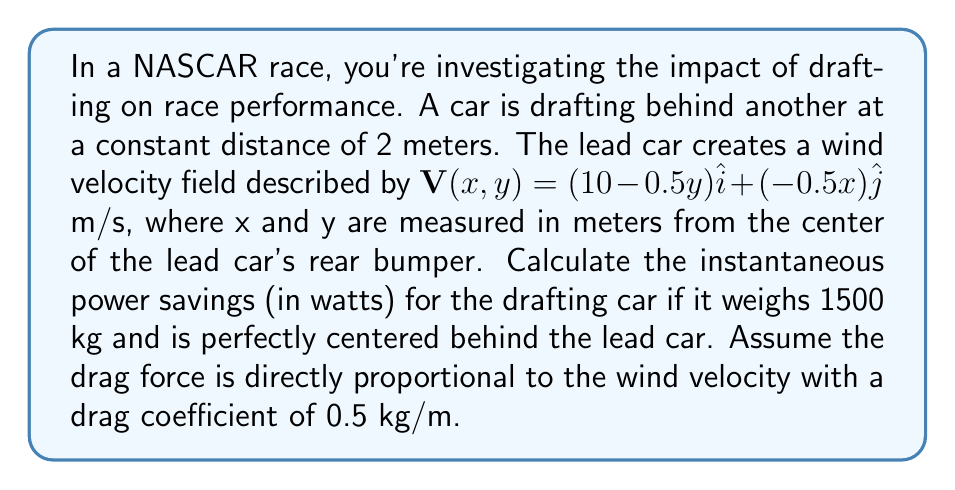Could you help me with this problem? To solve this problem, we'll follow these steps:

1) First, we need to find the wind velocity at the position of the drafting car. The car is 2 meters directly behind the lead car, so its position is (0, -2) in our coordinate system.

2) Plug this position into the vector field equation:
   $\mathbf{V}(0,-2) = (10-0.5(-2))\hat{i} + (-0.5(0))\hat{j}$
   $= (10+1)\hat{i} + 0\hat{j} = 11\hat{i}$ m/s

3) The wind velocity experienced by the drafting car is 11 m/s in the positive x-direction.

4) The drag force is proportional to the wind velocity:
   $\mathbf{F} = -k\mathbf{V}$ where k = 0.5 kg/m
   $\mathbf{F} = -0.5 \cdot 11\hat{i} = -5.5\hat{i}$ N

5) Power is force times velocity. The car's velocity relative to the ground is the difference between its speed and the wind speed. If we assume the car is moving at the same speed as the lead car (which is reasonable in drafting), its velocity relative to the ground is:
   $\mathbf{v} = (10-11)\hat{i} = -1\hat{i}$ m/s

6) Now we can calculate the power:
   $P = \mathbf{F} \cdot \mathbf{v} = (-5.5\hat{i}) \cdot (-1\hat{i}) = 5.5$ W

7) This is the power savings due to drafting. Without drafting, the car would experience the full 10 m/s headwind, resulting in a drag force of -5 N and a power loss of 50 W.

Therefore, the instantaneous power savings is 50 W - 5.5 W = 44.5 W.
Answer: 44.5 W 